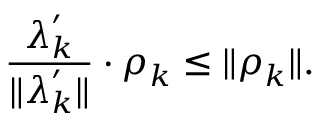Convert formula to latex. <formula><loc_0><loc_0><loc_500><loc_500>\frac { \lambda _ { k } ^ { \prime } } { \| \lambda _ { k } ^ { \prime } \| } \cdot \rho _ { k } \leq \| \rho _ { k } \| .</formula> 